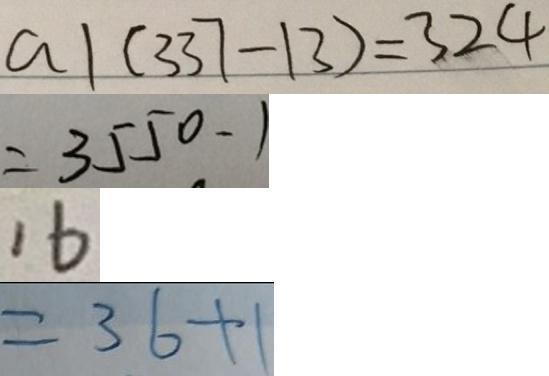<formula> <loc_0><loc_0><loc_500><loc_500>a \vert ( 3 3 7 - 1 3 ) = 3 2 4 
 = 3 5 5 0 - 1 
 1 6 
 = 3 6 + 1</formula> 